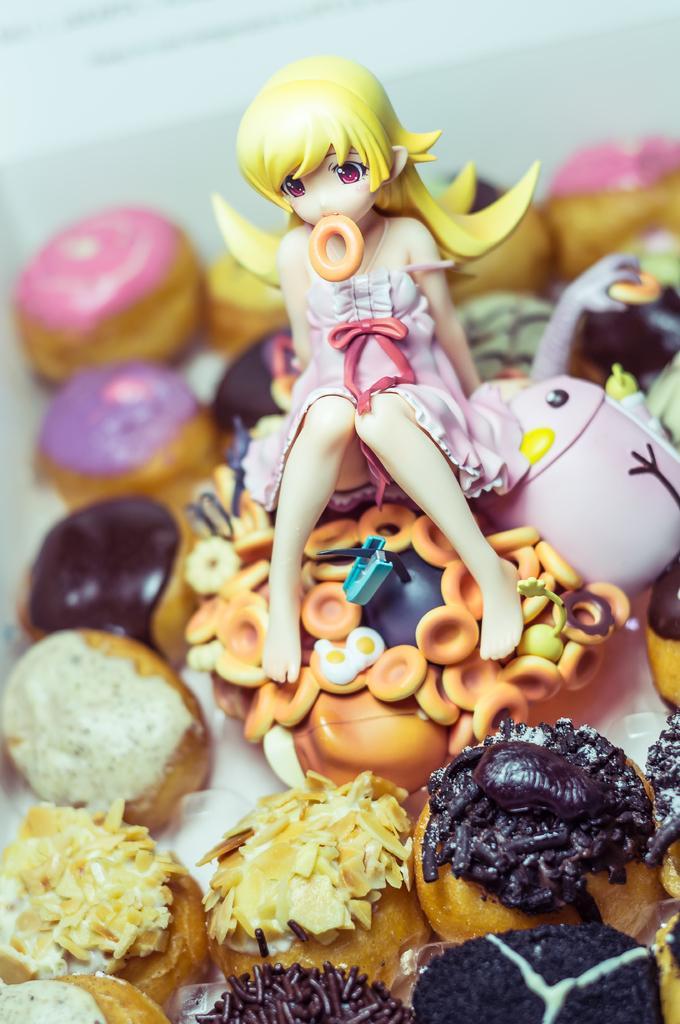In one or two sentences, can you explain what this image depicts? In this picture, we see the doll in the pink dress. At the bottom, we see the doughnuts. In the background, we see the doughnuts. At the top, it is white in color. This picture is blurred in the background. 